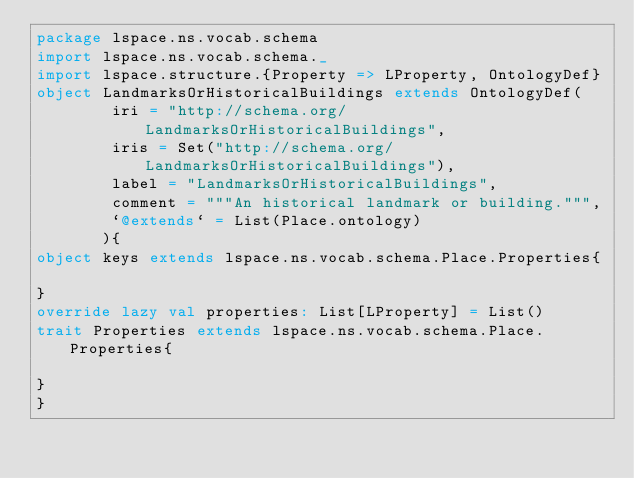Convert code to text. <code><loc_0><loc_0><loc_500><loc_500><_Scala_>package lspace.ns.vocab.schema
import lspace.ns.vocab.schema._
import lspace.structure.{Property => LProperty, OntologyDef}
object LandmarksOrHistoricalBuildings extends OntologyDef(
        iri = "http://schema.org/LandmarksOrHistoricalBuildings",
        iris = Set("http://schema.org/LandmarksOrHistoricalBuildings"),
        label = "LandmarksOrHistoricalBuildings",
        comment = """An historical landmark or building.""",
        `@extends` = List(Place.ontology)
       ){
object keys extends lspace.ns.vocab.schema.Place.Properties{

}
override lazy val properties: List[LProperty] = List()
trait Properties extends lspace.ns.vocab.schema.Place.Properties{

}
}</code> 